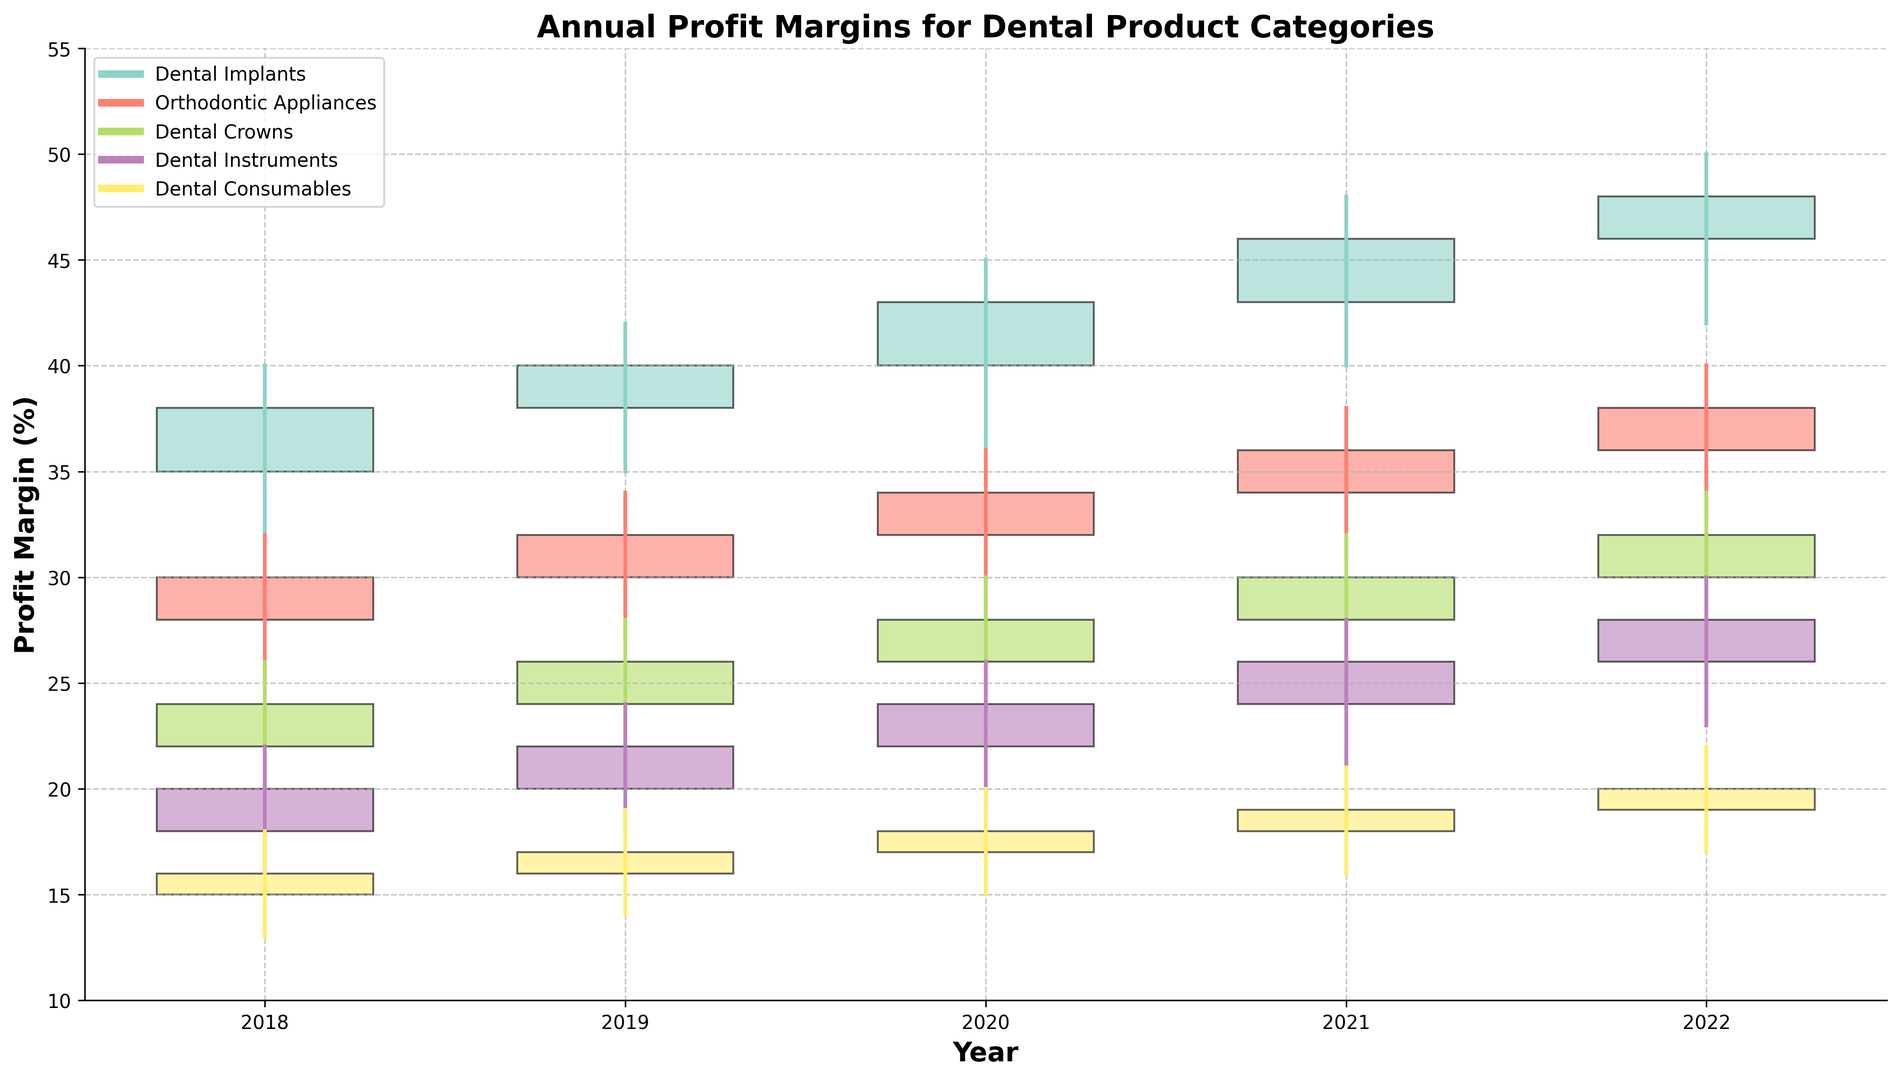What's the highest profit margin for Dental Implants? To find the highest profit margin for Dental Implants, look for the "High" value among all years. The highest value is 50%.
Answer: 50% Which category had the lowest profit margin in 2020? To determine this, compare the "Low" values for all categories in 2020. Dental Instruments had the lowest "Low" value of 19%.
Answer: Dental Instruments What was the average closing profit margin for Orthodontic Appliances from 2018 to 2022? Sum the "Close" values for each year (30 + 32 + 34 + 36 + 38 = 170) and then divide by the number of years (5). The average is 170 / 5 = 34%.
Answer: 34% How much did the closing profit margin for Dental Consumables increase from 2018 to 2022? Subtract the "Close" value of 2018 from the "Close" value of 2022 (20 - 16). The increase is 4%.
Answer: 4% Which category had the smallest range between the highest and lowest profit margins in 2021? Calculate the range by subtracting "Low" from "High" for each category in 2021:
- Dental Implants: 48 - 40 = 8
- Orthodontic Appliances: 38 - 31 = 7
- Dental Crowns: 32 - 25 = 7
- Dental Instruments: 28 - 21 = 7
- Dental Consumables: 21 - 16 = 5
Dental Consumables had the smallest range.
Answer: Dental Consumables Which product category had the most remarkable upward trend in closing profit margins from 2018 to 2022? Analyze each category's "Close" values comparing 2018 to 2022 and their progression:
- Dental Implants: 38 to 48 (10% increase)
- Orthodontic Appliances: 30 to 38 (8% increase)
- Dental Crowns: 24 to 32 (8% increase)
- Dental Instruments: 20 to 28 (8% increase)
- Dental Consumables: 16 to 20 (4% increase)
Dental Implants had the most remarkable upward trend with a 10% increase.
Answer: Dental Implants Which year had the highest closing profit margin overall, and for which category? Scan for the highest "Close" value in the dataset. The highest value is 48% for Dental Implants in 2022.
Answer: 2022, Dental Implants Compare the highest "Open" value between Dental Crowns and Orthodontic Appliances in 2022. Which is higher? Look at the "Open" values for each category in 2022. For Dental Crowns, the "Open" value is 30%. For Orthodontic Appliances, it is 36%. Orthodontic Appliances' 36% is higher.
Answer: Orthodontic Appliances What is the cumulative range of profit margins (High - Low) for Dental Instruments from 2018 to 2022? For each year, find the range and sum them up: 
- 2018: 22 - 16 = 6
- 2019: 24 - 18 = 6
- 2020: 26 - 19 = 7
- 2021: 28 - 21 = 7
- 2022: 30 - 23 = 7
The cumulative range is 6 + 6 + 7 + 7 + 7 = 33.
Answer: 33 